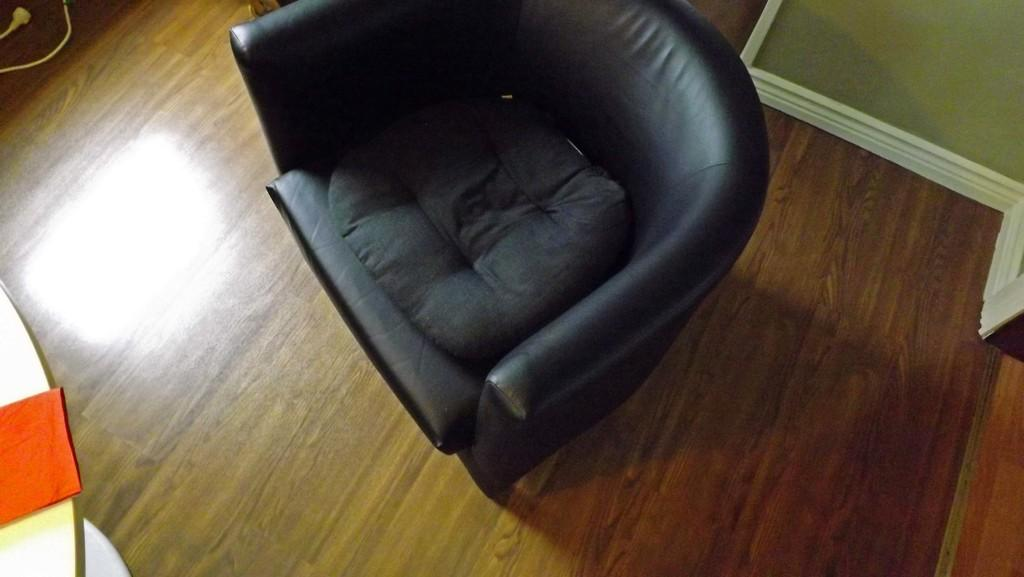What type of furniture is in the image? There is a couch in the image. What color is the couch? The couch is black. What colors are on the wall in the background? The wall in the background is green and white. What is the color of the wire visible in the image? The wire is white. Can you see a hat on the couch in the image? There is no hat present on the couch in the image. Is there a rail visible in the image? There is no rail present in the image. 